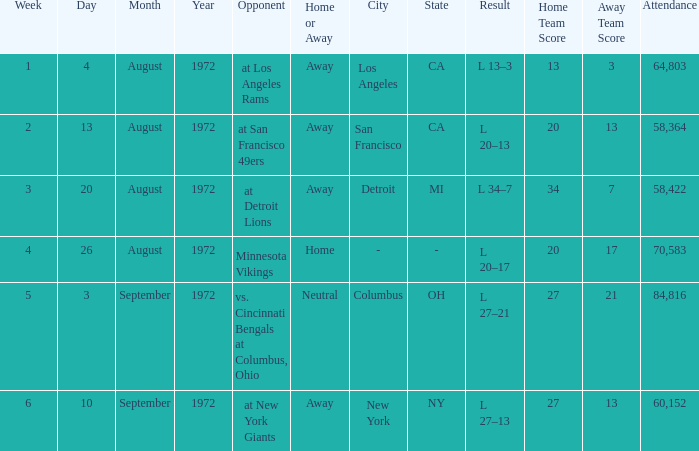Write the full table. {'header': ['Week', 'Day', 'Month', 'Year', 'Opponent', 'Home or Away', 'City', 'State', 'Result', 'Home Team Score', 'Away Team Score', 'Attendance'], 'rows': [['1', '4', 'August', '1972', 'at Los Angeles Rams', 'Away', 'Los Angeles', 'CA', 'L 13–3', '13', '3', '64,803'], ['2', '13', 'August', '1972', 'at San Francisco 49ers', 'Away', 'San Francisco', 'CA', 'L 20–13', '20', '13', '58,364'], ['3', '20', 'August', '1972', 'at Detroit Lions', 'Away', 'Detroit', 'MI', 'L 34–7', '34', '7', '58,422'], ['4', '26', 'August', '1972', 'Minnesota Vikings', 'Home', '-', '-', 'L 20–17', '20', '17', '70,583'], ['5', '3', 'September', '1972', 'vs. Cincinnati Bengals at Columbus, Ohio', 'Neutral', 'Columbus', 'OH', 'L 27–21', '27', '21', '84,816'], ['6', '10', 'September', '1972', 'at New York Giants', 'Away', 'New York', 'NY', 'L 27–13', '27', '13', '60,152']]} What is the date of week 4? August 26, 1972. 